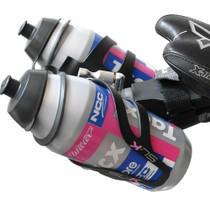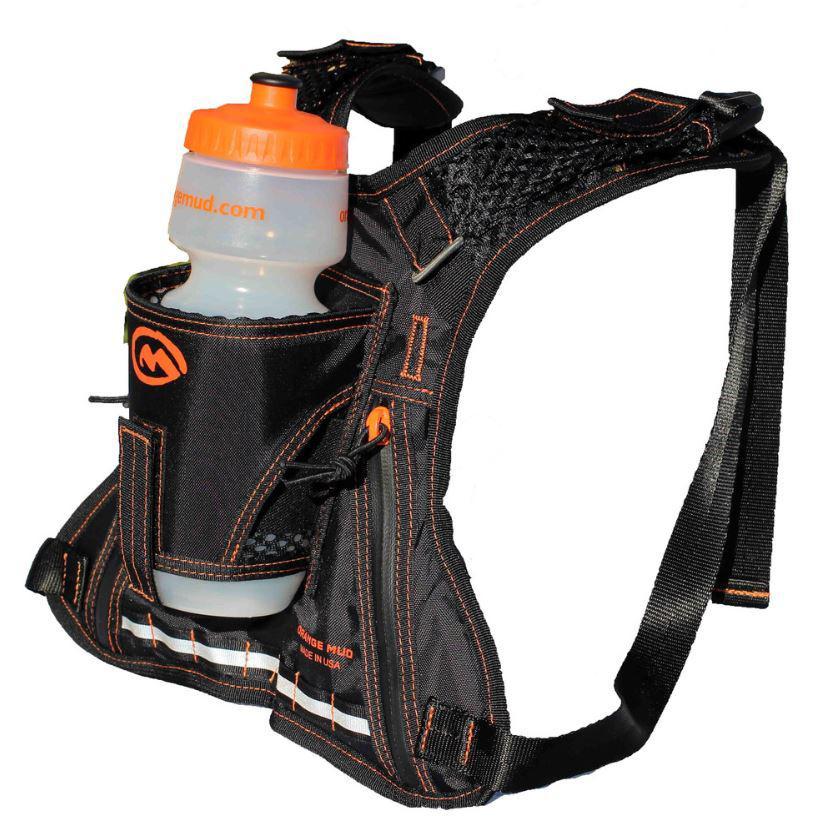The first image is the image on the left, the second image is the image on the right. Given the left and right images, does the statement "in the image on the left, there is at least 3 containers visible." hold true? Answer yes or no. No. 